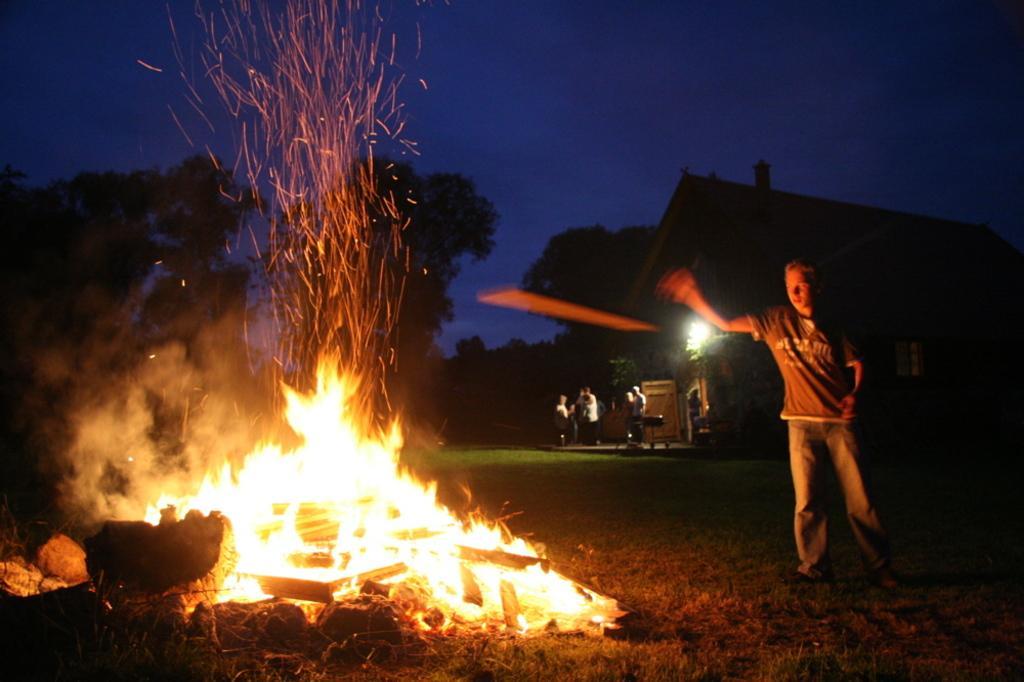Describe this image in one or two sentences. In this image I can see the person in-front of the fire. In the back I can see few more people. To the side of these people I can see the house and the light. In the background there are many trees and the blue sky. 